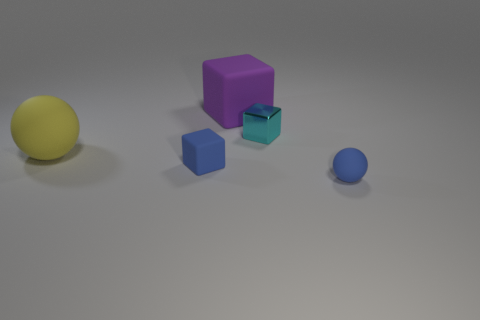Are there an equal number of blocks behind the purple object and spheres that are right of the large yellow sphere?
Make the answer very short. No. How many big gray shiny things are there?
Offer a very short reply. 0. Are there more blue balls that are to the left of the tiny cyan object than large yellow matte things?
Ensure brevity in your answer.  No. What material is the yellow thing that is in front of the tiny cyan metal object?
Provide a short and direct response. Rubber. There is a tiny rubber object that is the same shape as the big yellow rubber object; what color is it?
Keep it short and to the point. Blue. How many tiny objects have the same color as the small sphere?
Your answer should be very brief. 1. There is a rubber block to the left of the big purple rubber thing; does it have the same size as the matte thing behind the yellow ball?
Your answer should be compact. No. There is a blue rubber block; is it the same size as the rubber sphere that is to the right of the purple matte object?
Provide a succinct answer. Yes. The blue matte cube is what size?
Offer a very short reply. Small. What is the color of the small cube that is the same material as the yellow object?
Give a very brief answer. Blue. 